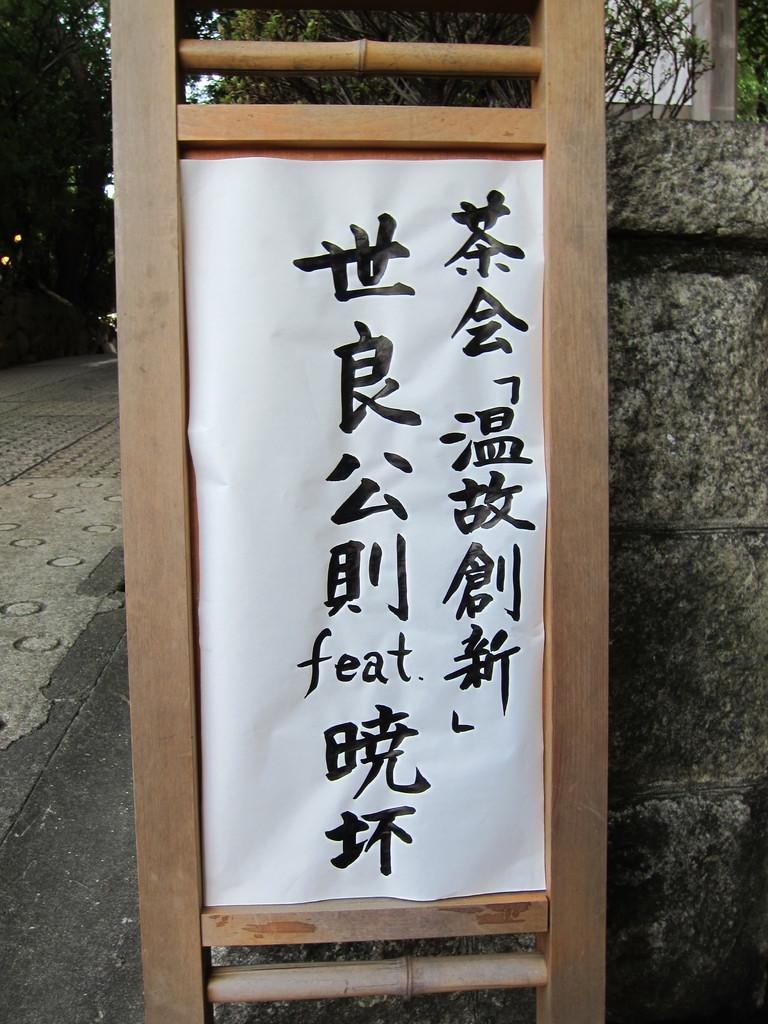What is the main object in the image? There is a board in the image. What is written or displayed on the board? There is text on the board. What can be seen in the background of the image? There are trees and a pavement in the background of the image. How many coughs can be heard in the image? There are no coughs present in the image, as it is a visual representation and not an audio recording. 